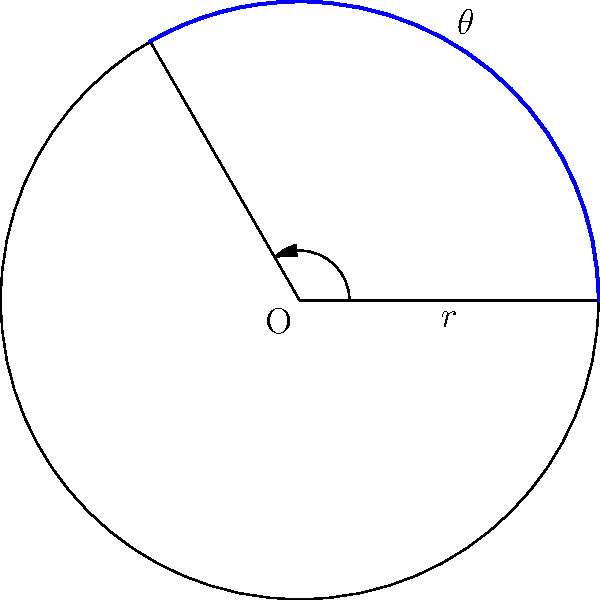In a circular sector with radius $r = 10$ cm and central angle $\theta = 120°$, calculate the area of the sector. Express your answer in terms of $\pi$ cm². How might this calculation be relevant in determining the coverage area for a specific grant allocation in Dr. Z's research project? To find the area of a circular sector, we follow these steps:

1) The formula for the area of a circular sector is:
   
   $$A = \frac{1}{2}r^2\theta$$

   Where $A$ is the area, $r$ is the radius, and $\theta$ is the central angle in radians.

2) We're given $r = 10$ cm and $\theta = 120°$. However, we need to convert the angle to radians:
   
   $$120° = 120 \cdot \frac{\pi}{180} = \frac{2\pi}{3}$$ radians

3) Now we can substitute these values into our formula:

   $$A = \frac{1}{2} \cdot 10^2 \cdot \frac{2\pi}{3}$$

4) Simplify:
   
   $$A = \frac{1}{2} \cdot 100 \cdot \frac{2\pi}{3} = \frac{100\pi}{3}$$ cm²

This calculation could be relevant in determining the coverage area for a specific grant allocation in Dr. Z's research project by providing a precise measurement of a circular study area or resource distribution zone. The program officer could use this to ensure that the acknowledged financial support accurately reflects the scope of the funded research area.
Answer: $\frac{100\pi}{3}$ cm² 